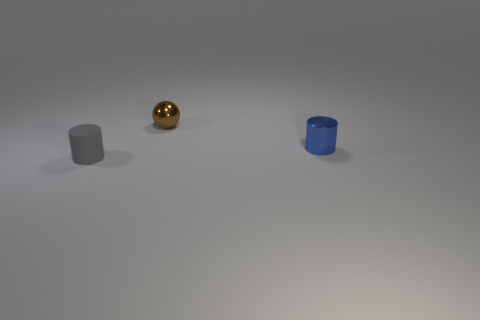Add 2 tiny spheres. How many objects exist? 5 Subtract all cylinders. How many objects are left? 1 Subtract all tiny cylinders. Subtract all large cyan balls. How many objects are left? 1 Add 1 gray cylinders. How many gray cylinders are left? 2 Add 2 brown metal objects. How many brown metal objects exist? 3 Subtract 0 cyan blocks. How many objects are left? 3 